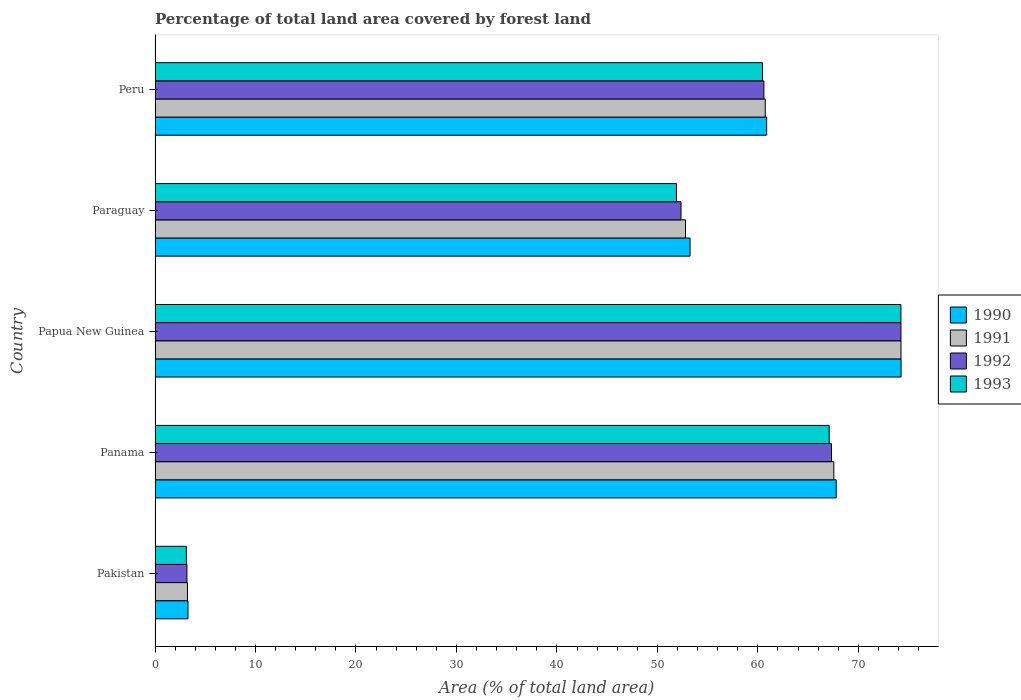How many groups of bars are there?
Keep it short and to the point. 5. Are the number of bars on each tick of the Y-axis equal?
Provide a short and direct response. Yes. In how many cases, is the number of bars for a given country not equal to the number of legend labels?
Provide a short and direct response. 0. What is the percentage of forest land in 1993 in Pakistan?
Your answer should be compact. 3.12. Across all countries, what is the maximum percentage of forest land in 1992?
Your answer should be compact. 74.24. Across all countries, what is the minimum percentage of forest land in 1991?
Your answer should be compact. 3.22. In which country was the percentage of forest land in 1992 maximum?
Offer a terse response. Papua New Guinea. What is the total percentage of forest land in 1992 in the graph?
Offer a very short reply. 257.7. What is the difference between the percentage of forest land in 1993 in Paraguay and that in Peru?
Keep it short and to the point. -8.56. What is the difference between the percentage of forest land in 1991 in Panama and the percentage of forest land in 1992 in Peru?
Your response must be concise. 6.97. What is the average percentage of forest land in 1992 per country?
Ensure brevity in your answer.  51.54. What is the difference between the percentage of forest land in 1991 and percentage of forest land in 1992 in Papua New Guinea?
Provide a succinct answer. 0.01. In how many countries, is the percentage of forest land in 1991 greater than 20 %?
Provide a short and direct response. 4. What is the ratio of the percentage of forest land in 1992 in Panama to that in Papua New Guinea?
Offer a very short reply. 0.91. What is the difference between the highest and the second highest percentage of forest land in 1993?
Keep it short and to the point. 7.14. What is the difference between the highest and the lowest percentage of forest land in 1991?
Offer a terse response. 71.02. Is the sum of the percentage of forest land in 1993 in Pakistan and Papua New Guinea greater than the maximum percentage of forest land in 1990 across all countries?
Your response must be concise. Yes. Is it the case that in every country, the sum of the percentage of forest land in 1991 and percentage of forest land in 1993 is greater than the sum of percentage of forest land in 1992 and percentage of forest land in 1990?
Ensure brevity in your answer.  No. How many bars are there?
Give a very brief answer. 20. Are all the bars in the graph horizontal?
Give a very brief answer. Yes. How many countries are there in the graph?
Your answer should be compact. 5. What is the difference between two consecutive major ticks on the X-axis?
Your response must be concise. 10. Are the values on the major ticks of X-axis written in scientific E-notation?
Keep it short and to the point. No. Does the graph contain grids?
Give a very brief answer. No. Where does the legend appear in the graph?
Give a very brief answer. Center right. How are the legend labels stacked?
Offer a very short reply. Vertical. What is the title of the graph?
Your answer should be compact. Percentage of total land area covered by forest land. What is the label or title of the X-axis?
Ensure brevity in your answer.  Area (% of total land area). What is the label or title of the Y-axis?
Make the answer very short. Country. What is the Area (% of total land area) in 1990 in Pakistan?
Offer a terse response. 3.28. What is the Area (% of total land area) in 1991 in Pakistan?
Offer a very short reply. 3.22. What is the Area (% of total land area) in 1992 in Pakistan?
Your response must be concise. 3.17. What is the Area (% of total land area) in 1993 in Pakistan?
Give a very brief answer. 3.12. What is the Area (% of total land area) in 1990 in Panama?
Your answer should be compact. 67.8. What is the Area (% of total land area) of 1991 in Panama?
Ensure brevity in your answer.  67.56. What is the Area (% of total land area) of 1992 in Panama?
Your response must be concise. 67.33. What is the Area (% of total land area) in 1993 in Panama?
Make the answer very short. 67.1. What is the Area (% of total land area) in 1990 in Papua New Guinea?
Ensure brevity in your answer.  74.25. What is the Area (% of total land area) in 1991 in Papua New Guinea?
Your response must be concise. 74.25. What is the Area (% of total land area) in 1992 in Papua New Guinea?
Keep it short and to the point. 74.24. What is the Area (% of total land area) of 1993 in Papua New Guinea?
Offer a terse response. 74.24. What is the Area (% of total land area) in 1990 in Paraguay?
Make the answer very short. 53.25. What is the Area (% of total land area) in 1991 in Paraguay?
Offer a terse response. 52.8. What is the Area (% of total land area) in 1992 in Paraguay?
Keep it short and to the point. 52.35. What is the Area (% of total land area) in 1993 in Paraguay?
Give a very brief answer. 51.9. What is the Area (% of total land area) of 1990 in Peru?
Provide a short and direct response. 60.88. What is the Area (% of total land area) in 1991 in Peru?
Provide a short and direct response. 60.74. What is the Area (% of total land area) in 1992 in Peru?
Provide a short and direct response. 60.6. What is the Area (% of total land area) of 1993 in Peru?
Your answer should be very brief. 60.46. Across all countries, what is the maximum Area (% of total land area) of 1990?
Offer a very short reply. 74.25. Across all countries, what is the maximum Area (% of total land area) of 1991?
Ensure brevity in your answer.  74.25. Across all countries, what is the maximum Area (% of total land area) of 1992?
Provide a short and direct response. 74.24. Across all countries, what is the maximum Area (% of total land area) in 1993?
Your answer should be compact. 74.24. Across all countries, what is the minimum Area (% of total land area) of 1990?
Ensure brevity in your answer.  3.28. Across all countries, what is the minimum Area (% of total land area) of 1991?
Your response must be concise. 3.22. Across all countries, what is the minimum Area (% of total land area) in 1992?
Your answer should be very brief. 3.17. Across all countries, what is the minimum Area (% of total land area) of 1993?
Your answer should be compact. 3.12. What is the total Area (% of total land area) in 1990 in the graph?
Offer a terse response. 259.46. What is the total Area (% of total land area) in 1991 in the graph?
Provide a succinct answer. 258.58. What is the total Area (% of total land area) in 1992 in the graph?
Offer a terse response. 257.7. What is the total Area (% of total land area) in 1993 in the graph?
Offer a very short reply. 256.81. What is the difference between the Area (% of total land area) of 1990 in Pakistan and that in Panama?
Your answer should be very brief. -64.52. What is the difference between the Area (% of total land area) in 1991 in Pakistan and that in Panama?
Make the answer very short. -64.34. What is the difference between the Area (% of total land area) in 1992 in Pakistan and that in Panama?
Make the answer very short. -64.16. What is the difference between the Area (% of total land area) of 1993 in Pakistan and that in Panama?
Keep it short and to the point. -63.98. What is the difference between the Area (% of total land area) of 1990 in Pakistan and that in Papua New Guinea?
Provide a short and direct response. -70.98. What is the difference between the Area (% of total land area) of 1991 in Pakistan and that in Papua New Guinea?
Make the answer very short. -71.02. What is the difference between the Area (% of total land area) in 1992 in Pakistan and that in Papua New Guinea?
Keep it short and to the point. -71.07. What is the difference between the Area (% of total land area) of 1993 in Pakistan and that in Papua New Guinea?
Keep it short and to the point. -71.12. What is the difference between the Area (% of total land area) of 1990 in Pakistan and that in Paraguay?
Offer a terse response. -49.97. What is the difference between the Area (% of total land area) of 1991 in Pakistan and that in Paraguay?
Give a very brief answer. -49.58. What is the difference between the Area (% of total land area) of 1992 in Pakistan and that in Paraguay?
Your answer should be compact. -49.18. What is the difference between the Area (% of total land area) of 1993 in Pakistan and that in Paraguay?
Offer a very short reply. -48.78. What is the difference between the Area (% of total land area) of 1990 in Pakistan and that in Peru?
Your answer should be very brief. -57.6. What is the difference between the Area (% of total land area) in 1991 in Pakistan and that in Peru?
Offer a very short reply. -57.51. What is the difference between the Area (% of total land area) of 1992 in Pakistan and that in Peru?
Keep it short and to the point. -57.43. What is the difference between the Area (% of total land area) of 1993 in Pakistan and that in Peru?
Ensure brevity in your answer.  -57.34. What is the difference between the Area (% of total land area) in 1990 in Panama and that in Papua New Guinea?
Make the answer very short. -6.46. What is the difference between the Area (% of total land area) of 1991 in Panama and that in Papua New Guinea?
Offer a terse response. -6.68. What is the difference between the Area (% of total land area) in 1992 in Panama and that in Papua New Guinea?
Your answer should be very brief. -6.91. What is the difference between the Area (% of total land area) of 1993 in Panama and that in Papua New Guinea?
Ensure brevity in your answer.  -7.14. What is the difference between the Area (% of total land area) in 1990 in Panama and that in Paraguay?
Make the answer very short. 14.54. What is the difference between the Area (% of total land area) in 1991 in Panama and that in Paraguay?
Offer a terse response. 14.76. What is the difference between the Area (% of total land area) of 1992 in Panama and that in Paraguay?
Your response must be concise. 14.98. What is the difference between the Area (% of total land area) in 1993 in Panama and that in Paraguay?
Your response must be concise. 15.2. What is the difference between the Area (% of total land area) in 1990 in Panama and that in Peru?
Your answer should be very brief. 6.92. What is the difference between the Area (% of total land area) of 1991 in Panama and that in Peru?
Your response must be concise. 6.83. What is the difference between the Area (% of total land area) of 1992 in Panama and that in Peru?
Your answer should be compact. 6.73. What is the difference between the Area (% of total land area) of 1993 in Panama and that in Peru?
Your answer should be compact. 6.64. What is the difference between the Area (% of total land area) in 1990 in Papua New Guinea and that in Paraguay?
Offer a very short reply. 21. What is the difference between the Area (% of total land area) in 1991 in Papua New Guinea and that in Paraguay?
Give a very brief answer. 21.45. What is the difference between the Area (% of total land area) in 1992 in Papua New Guinea and that in Paraguay?
Keep it short and to the point. 21.89. What is the difference between the Area (% of total land area) in 1993 in Papua New Guinea and that in Paraguay?
Keep it short and to the point. 22.34. What is the difference between the Area (% of total land area) in 1990 in Papua New Guinea and that in Peru?
Ensure brevity in your answer.  13.38. What is the difference between the Area (% of total land area) of 1991 in Papua New Guinea and that in Peru?
Provide a short and direct response. 13.51. What is the difference between the Area (% of total land area) in 1992 in Papua New Guinea and that in Peru?
Ensure brevity in your answer.  13.64. What is the difference between the Area (% of total land area) of 1993 in Papua New Guinea and that in Peru?
Your answer should be compact. 13.78. What is the difference between the Area (% of total land area) of 1990 in Paraguay and that in Peru?
Keep it short and to the point. -7.62. What is the difference between the Area (% of total land area) in 1991 in Paraguay and that in Peru?
Your answer should be compact. -7.94. What is the difference between the Area (% of total land area) of 1992 in Paraguay and that in Peru?
Ensure brevity in your answer.  -8.25. What is the difference between the Area (% of total land area) in 1993 in Paraguay and that in Peru?
Provide a short and direct response. -8.56. What is the difference between the Area (% of total land area) in 1990 in Pakistan and the Area (% of total land area) in 1991 in Panama?
Offer a very short reply. -64.29. What is the difference between the Area (% of total land area) of 1990 in Pakistan and the Area (% of total land area) of 1992 in Panama?
Keep it short and to the point. -64.05. What is the difference between the Area (% of total land area) of 1990 in Pakistan and the Area (% of total land area) of 1993 in Panama?
Provide a short and direct response. -63.82. What is the difference between the Area (% of total land area) in 1991 in Pakistan and the Area (% of total land area) in 1992 in Panama?
Make the answer very short. -64.11. What is the difference between the Area (% of total land area) of 1991 in Pakistan and the Area (% of total land area) of 1993 in Panama?
Make the answer very short. -63.87. What is the difference between the Area (% of total land area) in 1992 in Pakistan and the Area (% of total land area) in 1993 in Panama?
Offer a very short reply. -63.93. What is the difference between the Area (% of total land area) of 1990 in Pakistan and the Area (% of total land area) of 1991 in Papua New Guinea?
Your answer should be compact. -70.97. What is the difference between the Area (% of total land area) of 1990 in Pakistan and the Area (% of total land area) of 1992 in Papua New Guinea?
Give a very brief answer. -70.96. What is the difference between the Area (% of total land area) in 1990 in Pakistan and the Area (% of total land area) in 1993 in Papua New Guinea?
Your response must be concise. -70.96. What is the difference between the Area (% of total land area) in 1991 in Pakistan and the Area (% of total land area) in 1992 in Papua New Guinea?
Provide a succinct answer. -71.02. What is the difference between the Area (% of total land area) in 1991 in Pakistan and the Area (% of total land area) in 1993 in Papua New Guinea?
Offer a very short reply. -71.01. What is the difference between the Area (% of total land area) of 1992 in Pakistan and the Area (% of total land area) of 1993 in Papua New Guinea?
Offer a very short reply. -71.07. What is the difference between the Area (% of total land area) in 1990 in Pakistan and the Area (% of total land area) in 1991 in Paraguay?
Provide a short and direct response. -49.52. What is the difference between the Area (% of total land area) in 1990 in Pakistan and the Area (% of total land area) in 1992 in Paraguay?
Keep it short and to the point. -49.07. What is the difference between the Area (% of total land area) in 1990 in Pakistan and the Area (% of total land area) in 1993 in Paraguay?
Your answer should be very brief. -48.62. What is the difference between the Area (% of total land area) in 1991 in Pakistan and the Area (% of total land area) in 1992 in Paraguay?
Your answer should be very brief. -49.13. What is the difference between the Area (% of total land area) in 1991 in Pakistan and the Area (% of total land area) in 1993 in Paraguay?
Offer a terse response. -48.68. What is the difference between the Area (% of total land area) of 1992 in Pakistan and the Area (% of total land area) of 1993 in Paraguay?
Give a very brief answer. -48.73. What is the difference between the Area (% of total land area) in 1990 in Pakistan and the Area (% of total land area) in 1991 in Peru?
Provide a succinct answer. -57.46. What is the difference between the Area (% of total land area) of 1990 in Pakistan and the Area (% of total land area) of 1992 in Peru?
Provide a succinct answer. -57.32. What is the difference between the Area (% of total land area) of 1990 in Pakistan and the Area (% of total land area) of 1993 in Peru?
Give a very brief answer. -57.18. What is the difference between the Area (% of total land area) in 1991 in Pakistan and the Area (% of total land area) in 1992 in Peru?
Your response must be concise. -57.37. What is the difference between the Area (% of total land area) in 1991 in Pakistan and the Area (% of total land area) in 1993 in Peru?
Provide a short and direct response. -57.24. What is the difference between the Area (% of total land area) of 1992 in Pakistan and the Area (% of total land area) of 1993 in Peru?
Your answer should be very brief. -57.29. What is the difference between the Area (% of total land area) of 1990 in Panama and the Area (% of total land area) of 1991 in Papua New Guinea?
Your response must be concise. -6.45. What is the difference between the Area (% of total land area) of 1990 in Panama and the Area (% of total land area) of 1992 in Papua New Guinea?
Ensure brevity in your answer.  -6.45. What is the difference between the Area (% of total land area) in 1990 in Panama and the Area (% of total land area) in 1993 in Papua New Guinea?
Your response must be concise. -6.44. What is the difference between the Area (% of total land area) in 1991 in Panama and the Area (% of total land area) in 1992 in Papua New Guinea?
Make the answer very short. -6.68. What is the difference between the Area (% of total land area) in 1991 in Panama and the Area (% of total land area) in 1993 in Papua New Guinea?
Keep it short and to the point. -6.67. What is the difference between the Area (% of total land area) in 1992 in Panama and the Area (% of total land area) in 1993 in Papua New Guinea?
Offer a terse response. -6.91. What is the difference between the Area (% of total land area) of 1990 in Panama and the Area (% of total land area) of 1991 in Paraguay?
Offer a terse response. 14.99. What is the difference between the Area (% of total land area) in 1990 in Panama and the Area (% of total land area) in 1992 in Paraguay?
Ensure brevity in your answer.  15.45. What is the difference between the Area (% of total land area) of 1990 in Panama and the Area (% of total land area) of 1993 in Paraguay?
Your answer should be compact. 15.9. What is the difference between the Area (% of total land area) in 1991 in Panama and the Area (% of total land area) in 1992 in Paraguay?
Your response must be concise. 15.21. What is the difference between the Area (% of total land area) of 1991 in Panama and the Area (% of total land area) of 1993 in Paraguay?
Your answer should be very brief. 15.66. What is the difference between the Area (% of total land area) of 1992 in Panama and the Area (% of total land area) of 1993 in Paraguay?
Make the answer very short. 15.43. What is the difference between the Area (% of total land area) of 1990 in Panama and the Area (% of total land area) of 1991 in Peru?
Ensure brevity in your answer.  7.06. What is the difference between the Area (% of total land area) of 1990 in Panama and the Area (% of total land area) of 1992 in Peru?
Provide a short and direct response. 7.2. What is the difference between the Area (% of total land area) in 1990 in Panama and the Area (% of total land area) in 1993 in Peru?
Provide a succinct answer. 7.34. What is the difference between the Area (% of total land area) of 1991 in Panama and the Area (% of total land area) of 1992 in Peru?
Make the answer very short. 6.97. What is the difference between the Area (% of total land area) of 1991 in Panama and the Area (% of total land area) of 1993 in Peru?
Your answer should be very brief. 7.1. What is the difference between the Area (% of total land area) of 1992 in Panama and the Area (% of total land area) of 1993 in Peru?
Your answer should be compact. 6.87. What is the difference between the Area (% of total land area) in 1990 in Papua New Guinea and the Area (% of total land area) in 1991 in Paraguay?
Offer a terse response. 21.45. What is the difference between the Area (% of total land area) of 1990 in Papua New Guinea and the Area (% of total land area) of 1992 in Paraguay?
Ensure brevity in your answer.  21.9. What is the difference between the Area (% of total land area) in 1990 in Papua New Guinea and the Area (% of total land area) in 1993 in Paraguay?
Make the answer very short. 22.35. What is the difference between the Area (% of total land area) in 1991 in Papua New Guinea and the Area (% of total land area) in 1992 in Paraguay?
Your response must be concise. 21.9. What is the difference between the Area (% of total land area) of 1991 in Papua New Guinea and the Area (% of total land area) of 1993 in Paraguay?
Give a very brief answer. 22.35. What is the difference between the Area (% of total land area) in 1992 in Papua New Guinea and the Area (% of total land area) in 1993 in Paraguay?
Offer a terse response. 22.34. What is the difference between the Area (% of total land area) of 1990 in Papua New Guinea and the Area (% of total land area) of 1991 in Peru?
Keep it short and to the point. 13.52. What is the difference between the Area (% of total land area) in 1990 in Papua New Guinea and the Area (% of total land area) in 1992 in Peru?
Your answer should be compact. 13.66. What is the difference between the Area (% of total land area) in 1990 in Papua New Guinea and the Area (% of total land area) in 1993 in Peru?
Offer a terse response. 13.79. What is the difference between the Area (% of total land area) of 1991 in Papua New Guinea and the Area (% of total land area) of 1992 in Peru?
Provide a succinct answer. 13.65. What is the difference between the Area (% of total land area) in 1991 in Papua New Guinea and the Area (% of total land area) in 1993 in Peru?
Provide a succinct answer. 13.79. What is the difference between the Area (% of total land area) of 1992 in Papua New Guinea and the Area (% of total land area) of 1993 in Peru?
Give a very brief answer. 13.78. What is the difference between the Area (% of total land area) of 1990 in Paraguay and the Area (% of total land area) of 1991 in Peru?
Your answer should be very brief. -7.49. What is the difference between the Area (% of total land area) of 1990 in Paraguay and the Area (% of total land area) of 1992 in Peru?
Offer a very short reply. -7.35. What is the difference between the Area (% of total land area) in 1990 in Paraguay and the Area (% of total land area) in 1993 in Peru?
Your answer should be very brief. -7.21. What is the difference between the Area (% of total land area) in 1991 in Paraguay and the Area (% of total land area) in 1992 in Peru?
Keep it short and to the point. -7.8. What is the difference between the Area (% of total land area) in 1991 in Paraguay and the Area (% of total land area) in 1993 in Peru?
Keep it short and to the point. -7.66. What is the difference between the Area (% of total land area) in 1992 in Paraguay and the Area (% of total land area) in 1993 in Peru?
Provide a succinct answer. -8.11. What is the average Area (% of total land area) in 1990 per country?
Provide a short and direct response. 51.89. What is the average Area (% of total land area) of 1991 per country?
Give a very brief answer. 51.72. What is the average Area (% of total land area) in 1992 per country?
Provide a succinct answer. 51.54. What is the average Area (% of total land area) of 1993 per country?
Make the answer very short. 51.36. What is the difference between the Area (% of total land area) of 1990 and Area (% of total land area) of 1991 in Pakistan?
Ensure brevity in your answer.  0.05. What is the difference between the Area (% of total land area) in 1990 and Area (% of total land area) in 1992 in Pakistan?
Make the answer very short. 0.11. What is the difference between the Area (% of total land area) in 1990 and Area (% of total land area) in 1993 in Pakistan?
Ensure brevity in your answer.  0.16. What is the difference between the Area (% of total land area) in 1991 and Area (% of total land area) in 1992 in Pakistan?
Keep it short and to the point. 0.05. What is the difference between the Area (% of total land area) of 1991 and Area (% of total land area) of 1993 in Pakistan?
Your answer should be very brief. 0.11. What is the difference between the Area (% of total land area) of 1992 and Area (% of total land area) of 1993 in Pakistan?
Offer a terse response. 0.05. What is the difference between the Area (% of total land area) in 1990 and Area (% of total land area) in 1991 in Panama?
Offer a very short reply. 0.23. What is the difference between the Area (% of total land area) in 1990 and Area (% of total land area) in 1992 in Panama?
Ensure brevity in your answer.  0.47. What is the difference between the Area (% of total land area) in 1990 and Area (% of total land area) in 1993 in Panama?
Your answer should be very brief. 0.7. What is the difference between the Area (% of total land area) of 1991 and Area (% of total land area) of 1992 in Panama?
Your answer should be compact. 0.23. What is the difference between the Area (% of total land area) in 1991 and Area (% of total land area) in 1993 in Panama?
Provide a succinct answer. 0.47. What is the difference between the Area (% of total land area) in 1992 and Area (% of total land area) in 1993 in Panama?
Keep it short and to the point. 0.23. What is the difference between the Area (% of total land area) in 1990 and Area (% of total land area) in 1991 in Papua New Guinea?
Provide a short and direct response. 0.01. What is the difference between the Area (% of total land area) in 1990 and Area (% of total land area) in 1992 in Papua New Guinea?
Give a very brief answer. 0.01. What is the difference between the Area (% of total land area) of 1990 and Area (% of total land area) of 1993 in Papua New Guinea?
Provide a succinct answer. 0.02. What is the difference between the Area (% of total land area) in 1991 and Area (% of total land area) in 1992 in Papua New Guinea?
Keep it short and to the point. 0.01. What is the difference between the Area (% of total land area) of 1991 and Area (% of total land area) of 1993 in Papua New Guinea?
Provide a short and direct response. 0.01. What is the difference between the Area (% of total land area) of 1992 and Area (% of total land area) of 1993 in Papua New Guinea?
Keep it short and to the point. 0.01. What is the difference between the Area (% of total land area) of 1990 and Area (% of total land area) of 1991 in Paraguay?
Keep it short and to the point. 0.45. What is the difference between the Area (% of total land area) in 1990 and Area (% of total land area) in 1992 in Paraguay?
Your answer should be very brief. 0.9. What is the difference between the Area (% of total land area) of 1990 and Area (% of total land area) of 1993 in Paraguay?
Keep it short and to the point. 1.35. What is the difference between the Area (% of total land area) of 1991 and Area (% of total land area) of 1992 in Paraguay?
Your response must be concise. 0.45. What is the difference between the Area (% of total land area) in 1991 and Area (% of total land area) in 1993 in Paraguay?
Provide a short and direct response. 0.9. What is the difference between the Area (% of total land area) in 1992 and Area (% of total land area) in 1993 in Paraguay?
Ensure brevity in your answer.  0.45. What is the difference between the Area (% of total land area) of 1990 and Area (% of total land area) of 1991 in Peru?
Provide a succinct answer. 0.14. What is the difference between the Area (% of total land area) in 1990 and Area (% of total land area) in 1992 in Peru?
Make the answer very short. 0.28. What is the difference between the Area (% of total land area) of 1990 and Area (% of total land area) of 1993 in Peru?
Offer a terse response. 0.42. What is the difference between the Area (% of total land area) in 1991 and Area (% of total land area) in 1992 in Peru?
Offer a terse response. 0.14. What is the difference between the Area (% of total land area) in 1991 and Area (% of total land area) in 1993 in Peru?
Your answer should be compact. 0.28. What is the difference between the Area (% of total land area) in 1992 and Area (% of total land area) in 1993 in Peru?
Provide a short and direct response. 0.14. What is the ratio of the Area (% of total land area) in 1990 in Pakistan to that in Panama?
Offer a very short reply. 0.05. What is the ratio of the Area (% of total land area) of 1991 in Pakistan to that in Panama?
Your answer should be very brief. 0.05. What is the ratio of the Area (% of total land area) in 1992 in Pakistan to that in Panama?
Ensure brevity in your answer.  0.05. What is the ratio of the Area (% of total land area) of 1993 in Pakistan to that in Panama?
Provide a succinct answer. 0.05. What is the ratio of the Area (% of total land area) in 1990 in Pakistan to that in Papua New Guinea?
Offer a very short reply. 0.04. What is the ratio of the Area (% of total land area) of 1991 in Pakistan to that in Papua New Guinea?
Provide a short and direct response. 0.04. What is the ratio of the Area (% of total land area) of 1992 in Pakistan to that in Papua New Guinea?
Ensure brevity in your answer.  0.04. What is the ratio of the Area (% of total land area) of 1993 in Pakistan to that in Papua New Guinea?
Keep it short and to the point. 0.04. What is the ratio of the Area (% of total land area) in 1990 in Pakistan to that in Paraguay?
Offer a terse response. 0.06. What is the ratio of the Area (% of total land area) in 1991 in Pakistan to that in Paraguay?
Your response must be concise. 0.06. What is the ratio of the Area (% of total land area) of 1992 in Pakistan to that in Paraguay?
Keep it short and to the point. 0.06. What is the ratio of the Area (% of total land area) of 1993 in Pakistan to that in Paraguay?
Your answer should be compact. 0.06. What is the ratio of the Area (% of total land area) of 1990 in Pakistan to that in Peru?
Ensure brevity in your answer.  0.05. What is the ratio of the Area (% of total land area) of 1991 in Pakistan to that in Peru?
Keep it short and to the point. 0.05. What is the ratio of the Area (% of total land area) of 1992 in Pakistan to that in Peru?
Your answer should be compact. 0.05. What is the ratio of the Area (% of total land area) of 1993 in Pakistan to that in Peru?
Provide a short and direct response. 0.05. What is the ratio of the Area (% of total land area) in 1990 in Panama to that in Papua New Guinea?
Offer a very short reply. 0.91. What is the ratio of the Area (% of total land area) of 1991 in Panama to that in Papua New Guinea?
Your answer should be compact. 0.91. What is the ratio of the Area (% of total land area) of 1992 in Panama to that in Papua New Guinea?
Offer a very short reply. 0.91. What is the ratio of the Area (% of total land area) in 1993 in Panama to that in Papua New Guinea?
Provide a succinct answer. 0.9. What is the ratio of the Area (% of total land area) in 1990 in Panama to that in Paraguay?
Offer a terse response. 1.27. What is the ratio of the Area (% of total land area) in 1991 in Panama to that in Paraguay?
Your answer should be very brief. 1.28. What is the ratio of the Area (% of total land area) in 1992 in Panama to that in Paraguay?
Ensure brevity in your answer.  1.29. What is the ratio of the Area (% of total land area) of 1993 in Panama to that in Paraguay?
Provide a short and direct response. 1.29. What is the ratio of the Area (% of total land area) of 1990 in Panama to that in Peru?
Provide a succinct answer. 1.11. What is the ratio of the Area (% of total land area) in 1991 in Panama to that in Peru?
Ensure brevity in your answer.  1.11. What is the ratio of the Area (% of total land area) of 1992 in Panama to that in Peru?
Offer a very short reply. 1.11. What is the ratio of the Area (% of total land area) of 1993 in Panama to that in Peru?
Give a very brief answer. 1.11. What is the ratio of the Area (% of total land area) of 1990 in Papua New Guinea to that in Paraguay?
Offer a very short reply. 1.39. What is the ratio of the Area (% of total land area) of 1991 in Papua New Guinea to that in Paraguay?
Your response must be concise. 1.41. What is the ratio of the Area (% of total land area) in 1992 in Papua New Guinea to that in Paraguay?
Provide a short and direct response. 1.42. What is the ratio of the Area (% of total land area) of 1993 in Papua New Guinea to that in Paraguay?
Keep it short and to the point. 1.43. What is the ratio of the Area (% of total land area) in 1990 in Papua New Guinea to that in Peru?
Give a very brief answer. 1.22. What is the ratio of the Area (% of total land area) in 1991 in Papua New Guinea to that in Peru?
Provide a succinct answer. 1.22. What is the ratio of the Area (% of total land area) in 1992 in Papua New Guinea to that in Peru?
Give a very brief answer. 1.23. What is the ratio of the Area (% of total land area) of 1993 in Papua New Guinea to that in Peru?
Your response must be concise. 1.23. What is the ratio of the Area (% of total land area) in 1990 in Paraguay to that in Peru?
Your answer should be compact. 0.87. What is the ratio of the Area (% of total land area) of 1991 in Paraguay to that in Peru?
Provide a short and direct response. 0.87. What is the ratio of the Area (% of total land area) in 1992 in Paraguay to that in Peru?
Your answer should be compact. 0.86. What is the ratio of the Area (% of total land area) in 1993 in Paraguay to that in Peru?
Your answer should be very brief. 0.86. What is the difference between the highest and the second highest Area (% of total land area) of 1990?
Your response must be concise. 6.46. What is the difference between the highest and the second highest Area (% of total land area) in 1991?
Offer a terse response. 6.68. What is the difference between the highest and the second highest Area (% of total land area) of 1992?
Keep it short and to the point. 6.91. What is the difference between the highest and the second highest Area (% of total land area) in 1993?
Give a very brief answer. 7.14. What is the difference between the highest and the lowest Area (% of total land area) of 1990?
Your answer should be very brief. 70.98. What is the difference between the highest and the lowest Area (% of total land area) in 1991?
Offer a very short reply. 71.02. What is the difference between the highest and the lowest Area (% of total land area) of 1992?
Make the answer very short. 71.07. What is the difference between the highest and the lowest Area (% of total land area) of 1993?
Provide a short and direct response. 71.12. 